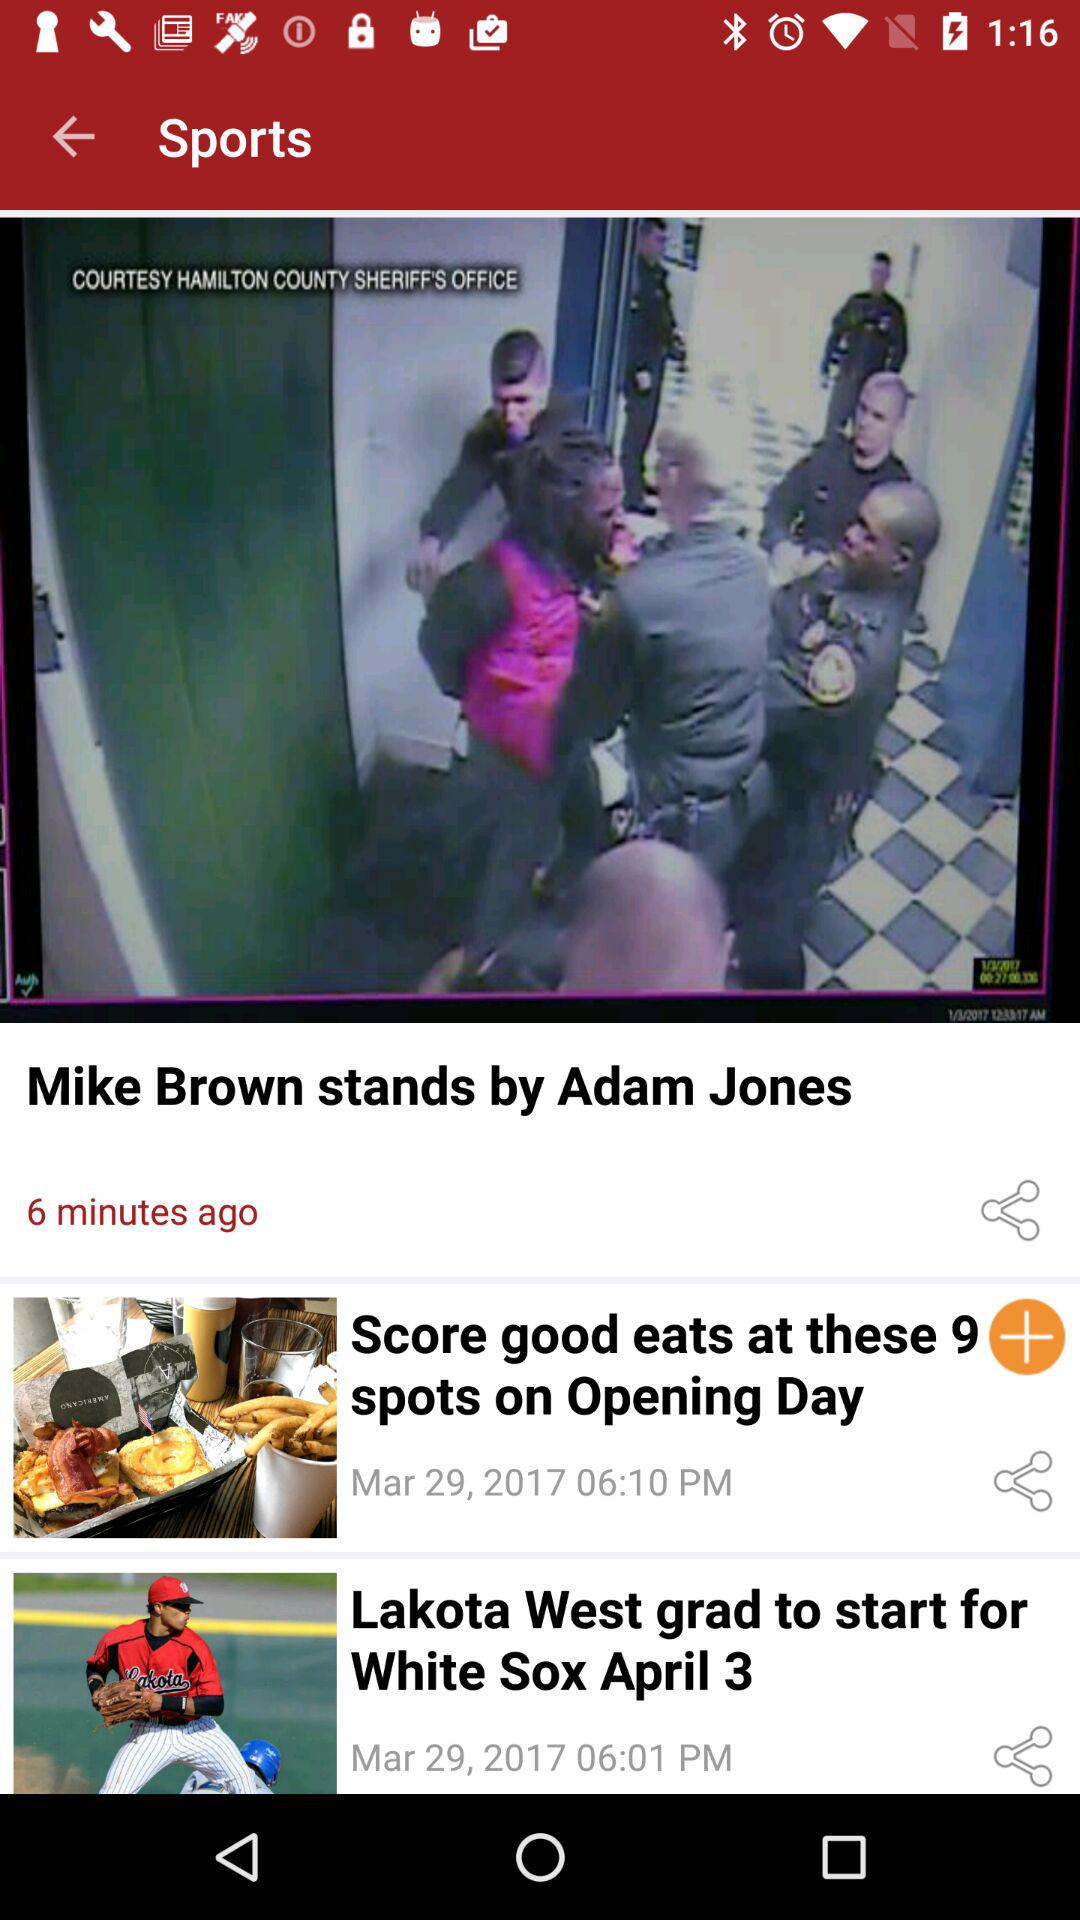What is the publication time of mike brown stands by adam jones?
When the provided information is insufficient, respond with <no answer>. <no answer> 